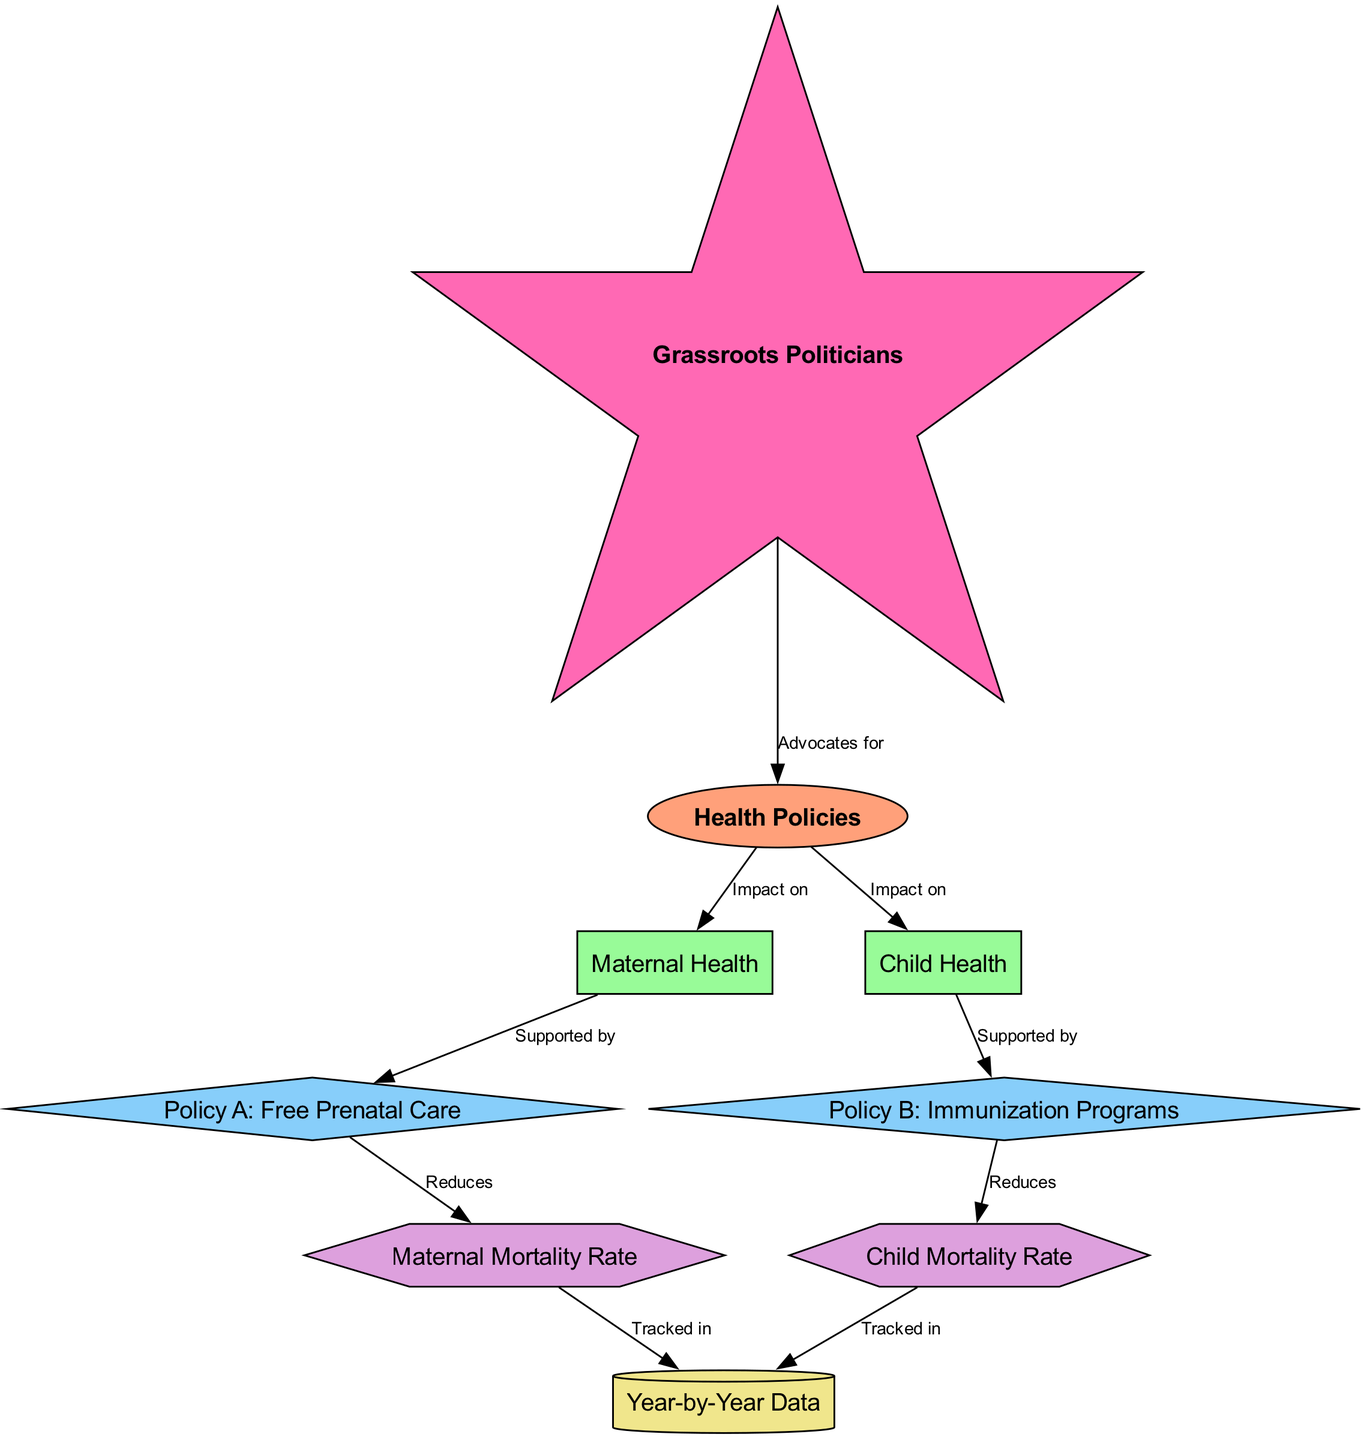What are the two categories affected by health policies? The diagram shows two categories that health policies impact: "Maternal Health" and "Child Health." This can be derived from the connections labeled "Impact on" leading to these categories from the central node "Health Policies."
Answer: Maternal Health, Child Health What is Policy A focused on? The label for Policy A is explicitly "Free Prenatal Care," indicating that this policy is focused on providing access to prenatal healthcare services. This is directly stated in the node labeled Policy A.
Answer: Free Prenatal Care How many policies are represented in the diagram? The diagram contains two policies: Policy A and Policy B. Each is represented as a distinct node in the graph, which can be counted.
Answer: 2 What outcome does Policy B aim to reduce? The diagram specifies that Policy B, which is linked to "Immunization Programs," aims to reduce the "Child Mortality Rate." This relationship is shown with an arrow leading from Policy B to the outcome indicating its effect.
Answer: Child Mortality Rate Which node advocates for health policies? In the diagram, the "Grassroots Politicians" node is connected to the "Health Policies" node with the label "Advocates for." This indicates that grassroots politicians play a role in supporting health policies.
Answer: Grassroots Politicians Which outcome is tracked in the yearly data? The diagram indicates that both "Maternal Mortality Rate" and "Child Mortality Rate" are tracked in "Year-by-Year Data." Each outcome has an arrow pointing to the "Yearly Data" node, denoting their tracking.
Answer: Maternal Mortality Rate, Child Mortality Rate What kind of relationship is depicted between "Policy A" and "Maternal Mortality Rate"? The relationship shown in the diagram indicates that Policy A is designed to "Reduces" the "Maternal Mortality Rate." This is illustrated by the edge leading from Policy A to that outcome.
Answer: Reduces Which influencer supports the health policies mentioned in the diagram? The "Grassroots Politicians" node is labeled with the relationship "Advocates for" leading to the "Health Policies" node, suggesting that grassroots politicians are influential in advocating for these policies.
Answer: Grassroots Politicians 